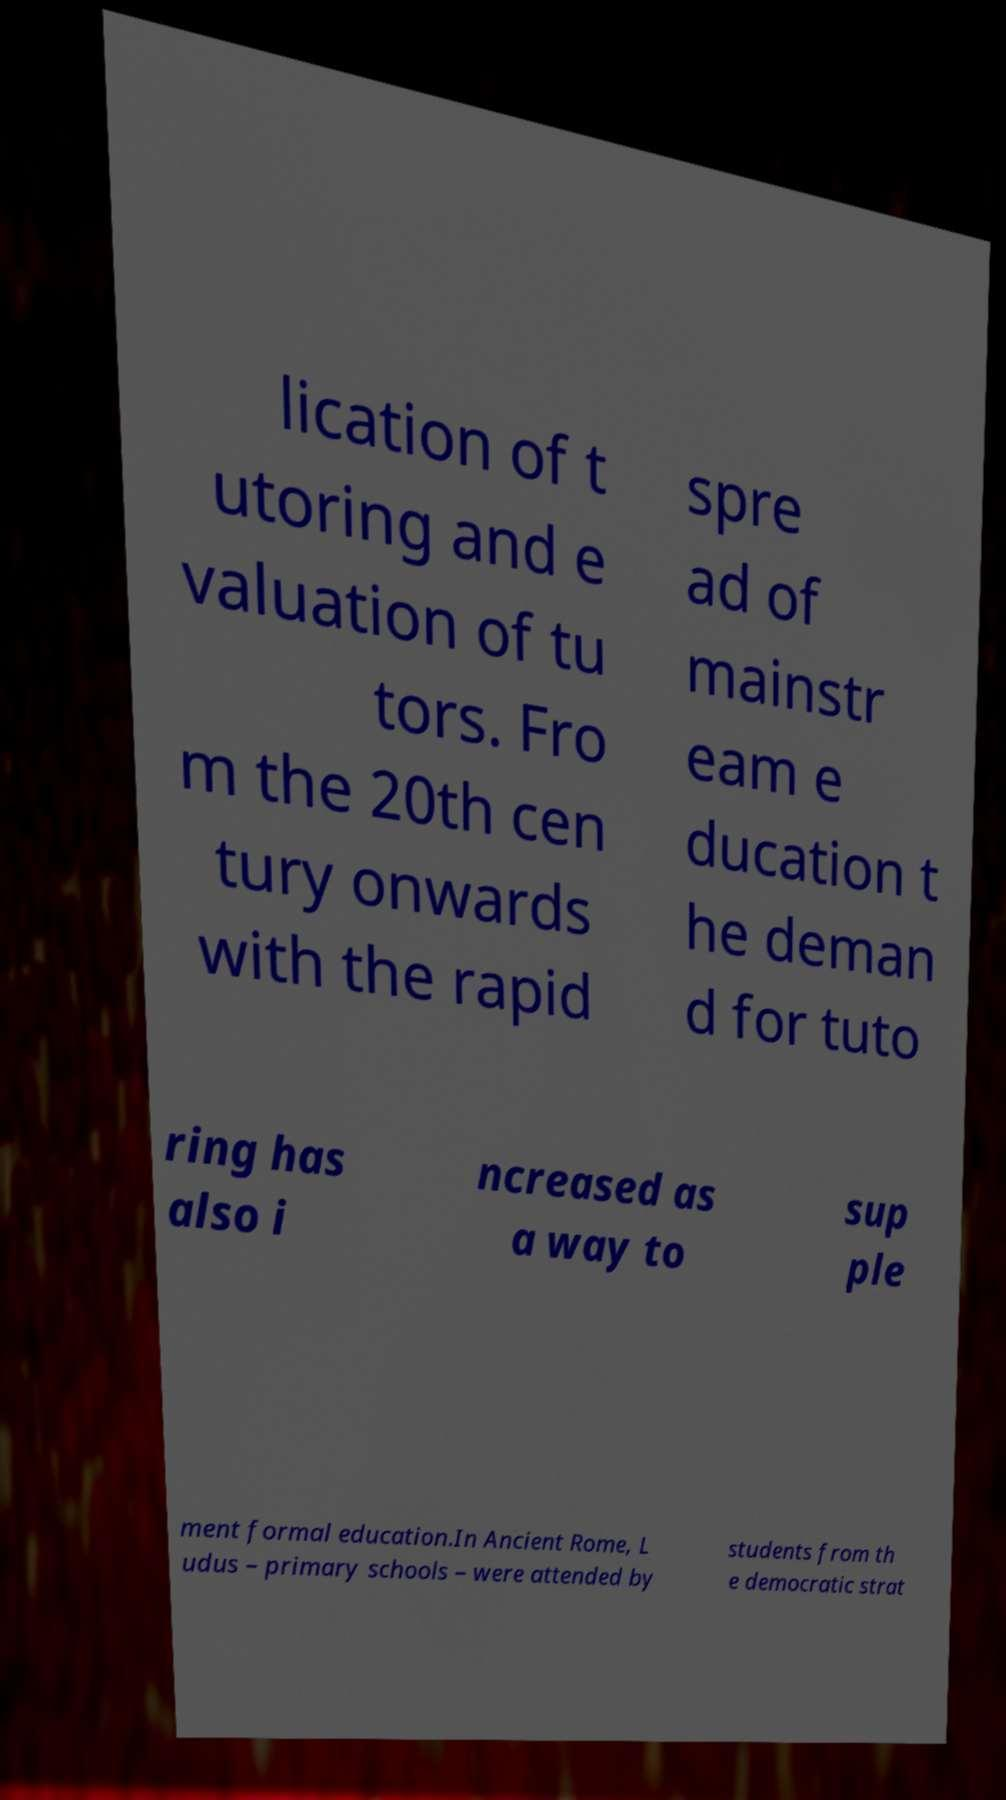What messages or text are displayed in this image? I need them in a readable, typed format. lication of t utoring and e valuation of tu tors. Fro m the 20th cen tury onwards with the rapid spre ad of mainstr eam e ducation t he deman d for tuto ring has also i ncreased as a way to sup ple ment formal education.In Ancient Rome, L udus – primary schools – were attended by students from th e democratic strat 